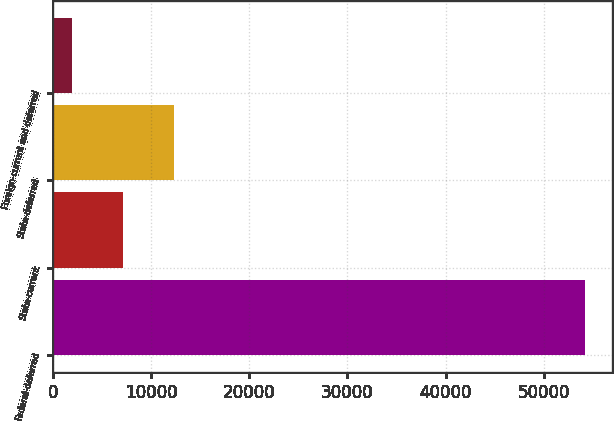<chart> <loc_0><loc_0><loc_500><loc_500><bar_chart><fcel>Federal-deferred<fcel>State-current<fcel>State-deferred<fcel>Foreign-current and deferred<nl><fcel>54237<fcel>7137.3<fcel>12370.6<fcel>1904<nl></chart> 